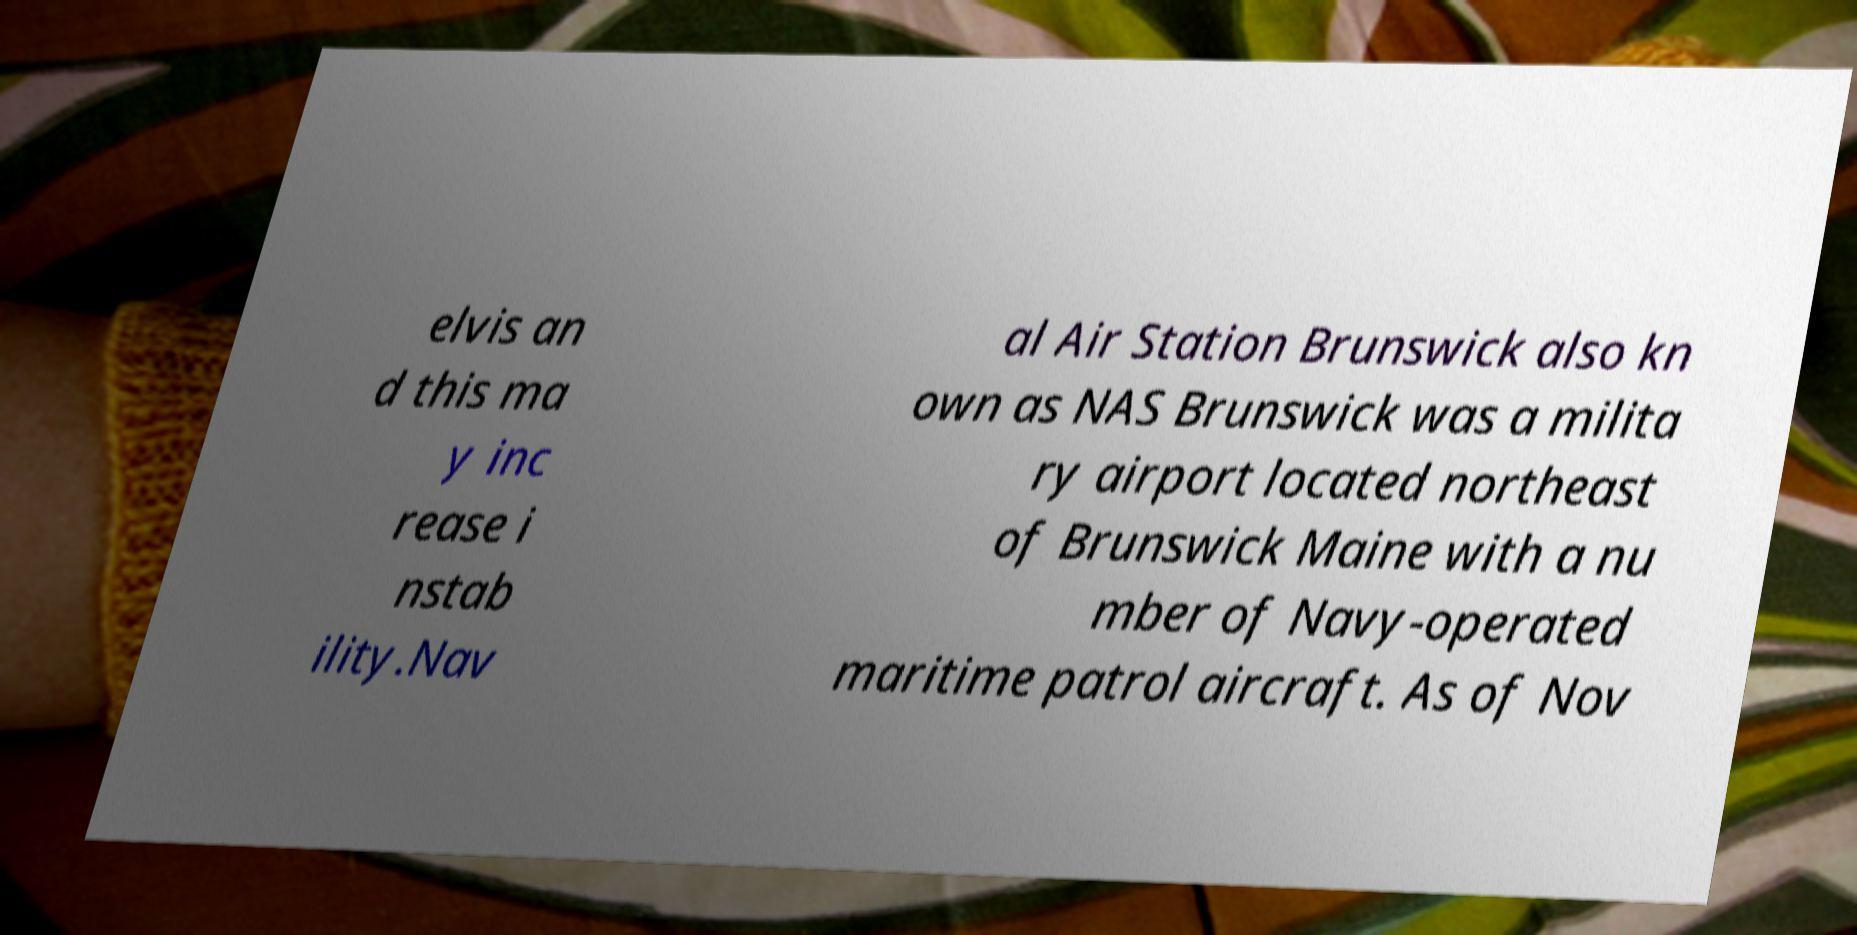For documentation purposes, I need the text within this image transcribed. Could you provide that? elvis an d this ma y inc rease i nstab ility.Nav al Air Station Brunswick also kn own as NAS Brunswick was a milita ry airport located northeast of Brunswick Maine with a nu mber of Navy-operated maritime patrol aircraft. As of Nov 